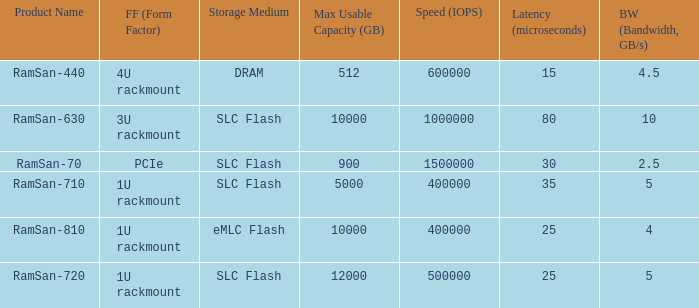List the range distroration for the ramsan-630 3U rackmount. 